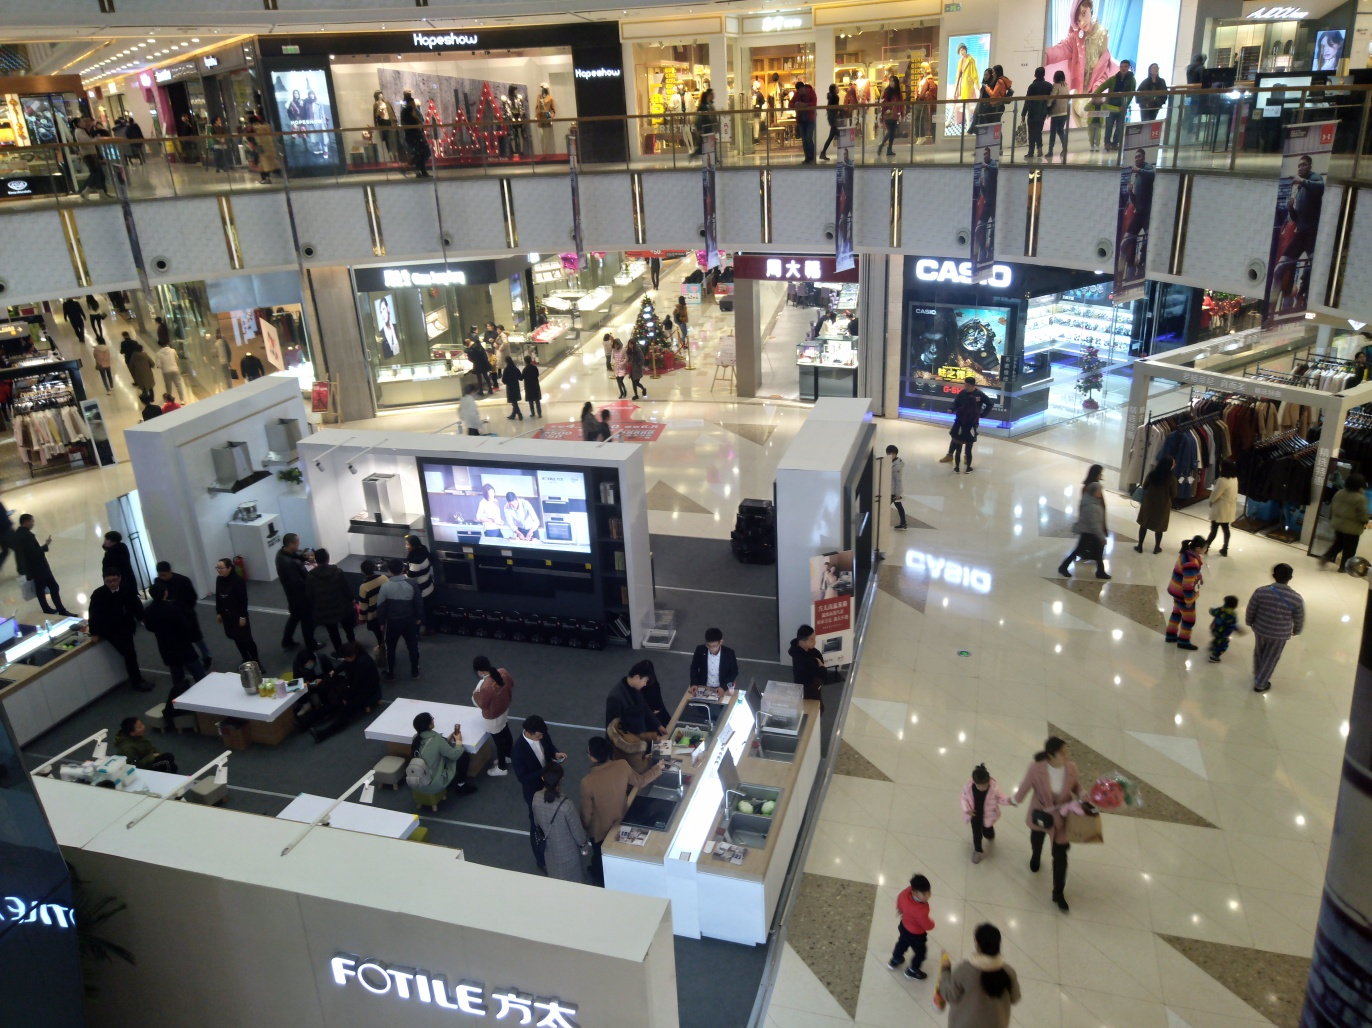What's the general activity happening in the mall? The mall is bustling with activity; there are shoppers walking around, some people are looking at the displays, and others are interacting with sales staff at the booths. The central aisle appears to be a primary thoroughfare for shoppers moving between stores. 